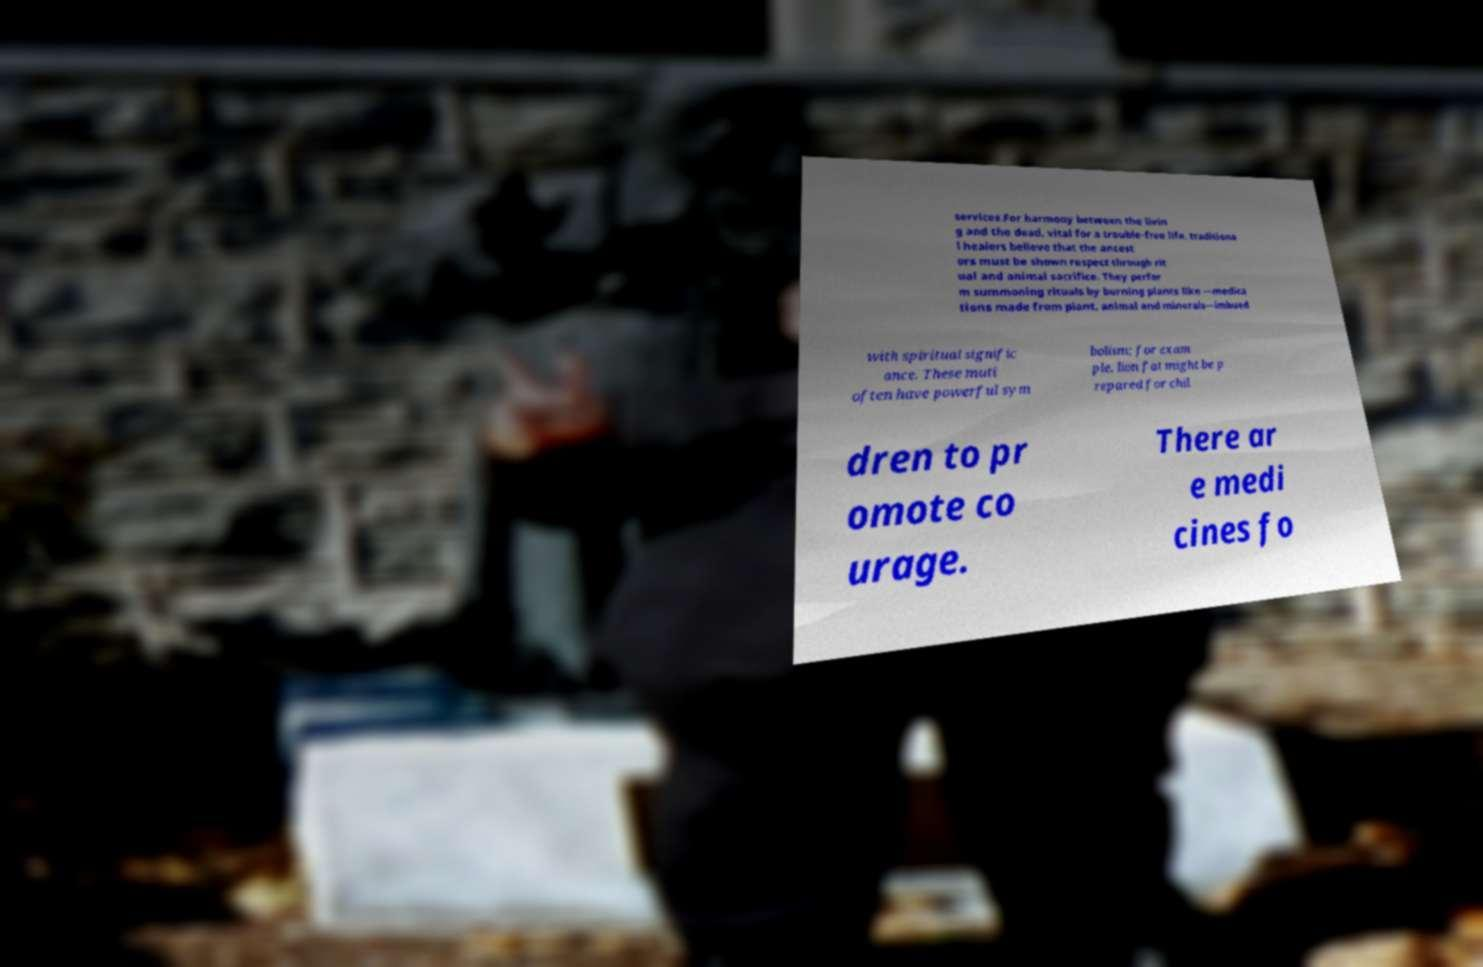Please read and relay the text visible in this image. What does it say? services.For harmony between the livin g and the dead, vital for a trouble-free life, traditiona l healers believe that the ancest ors must be shown respect through rit ual and animal sacrifice. They perfor m summoning rituals by burning plants like —medica tions made from plant, animal and minerals—imbued with spiritual signific ance. These muti often have powerful sym bolism; for exam ple, lion fat might be p repared for chil dren to pr omote co urage. There ar e medi cines fo 